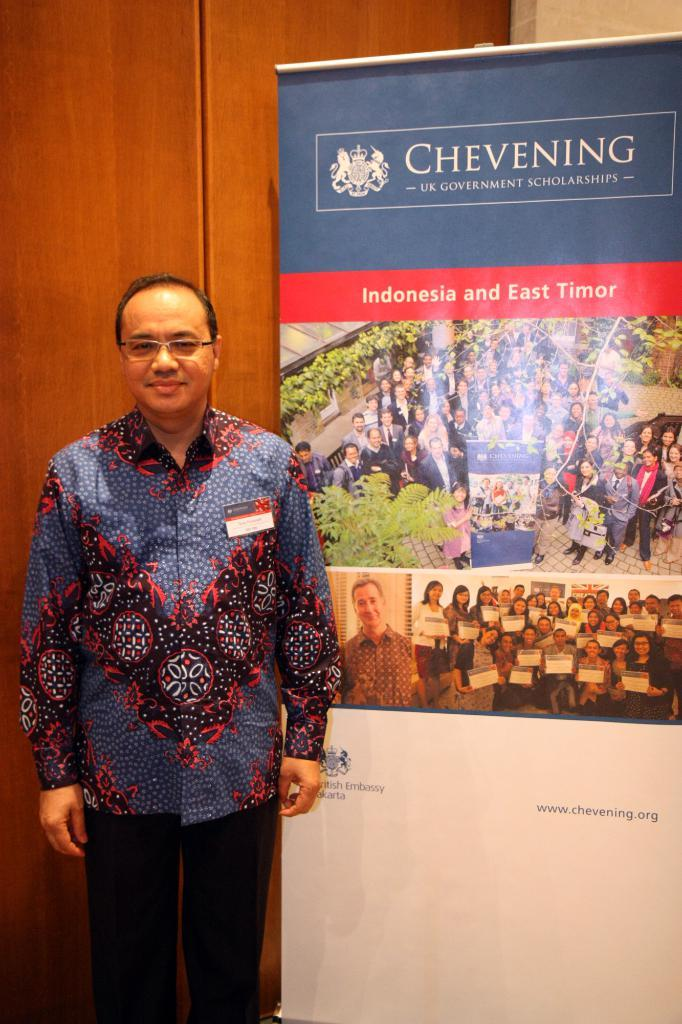What is the person standing near in the image? The person is standing near a banner. What can be found on the banner? The banner contains text and photographs. What is behind the person in the image? There is a wall behind the person. How does the crowd react to the zinc in the image? There is no crowd or zinc present in the image. What type of love is being expressed in the image? There is no expression of love in the image; it features a person standing near a banner with text and photographs. 